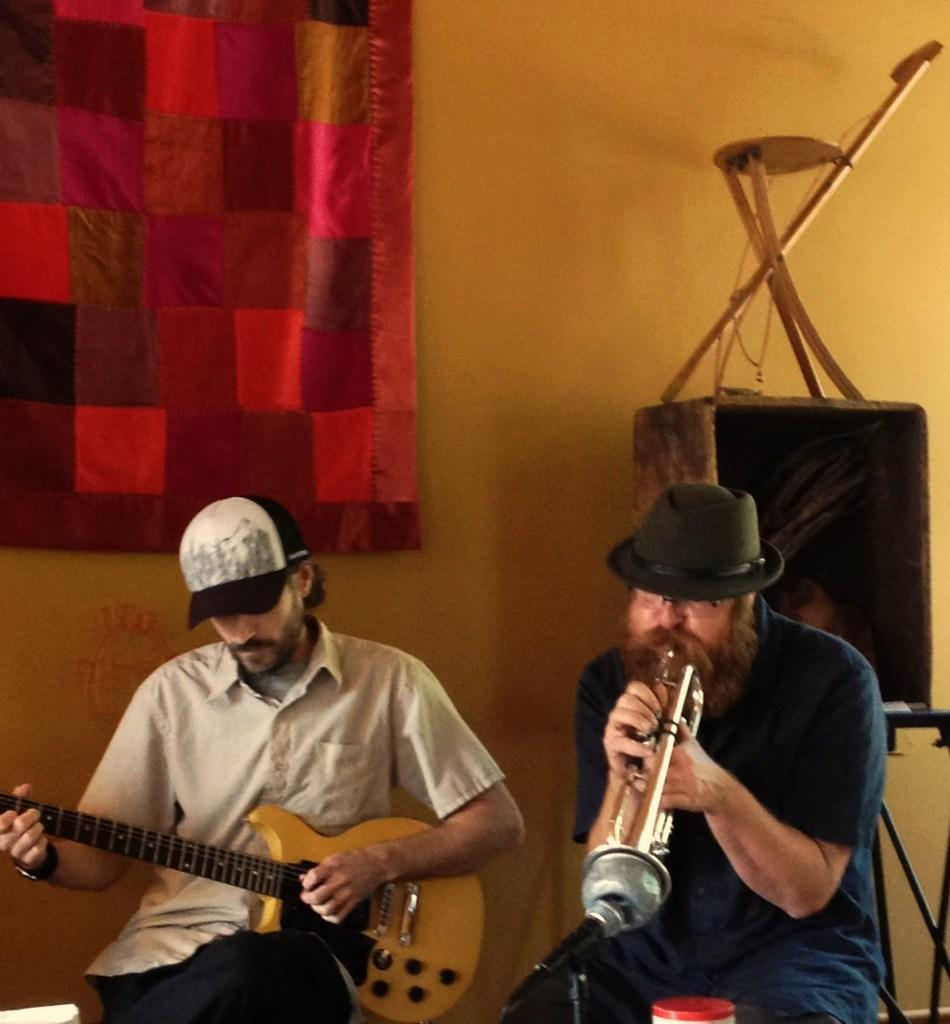What is the man in the image doing? The man is playing a trumpet. Are there any other people in the image? Yes, there is another man seated in the image. What is the second man doing? The second man is playing a guitar. What can be seen near a window in the image? There is a curtain near a window in the image. What type of furniture is on a table in the image? There is a foldable chair on a table in the image. What type of legal advice is the man providing in the image? There is no indication in the image that the man is providing legal advice, as he is playing a trumpet. What shape is the battlefield in the image? There is no battlefield present in the image; it features two men playing musical instruments. 